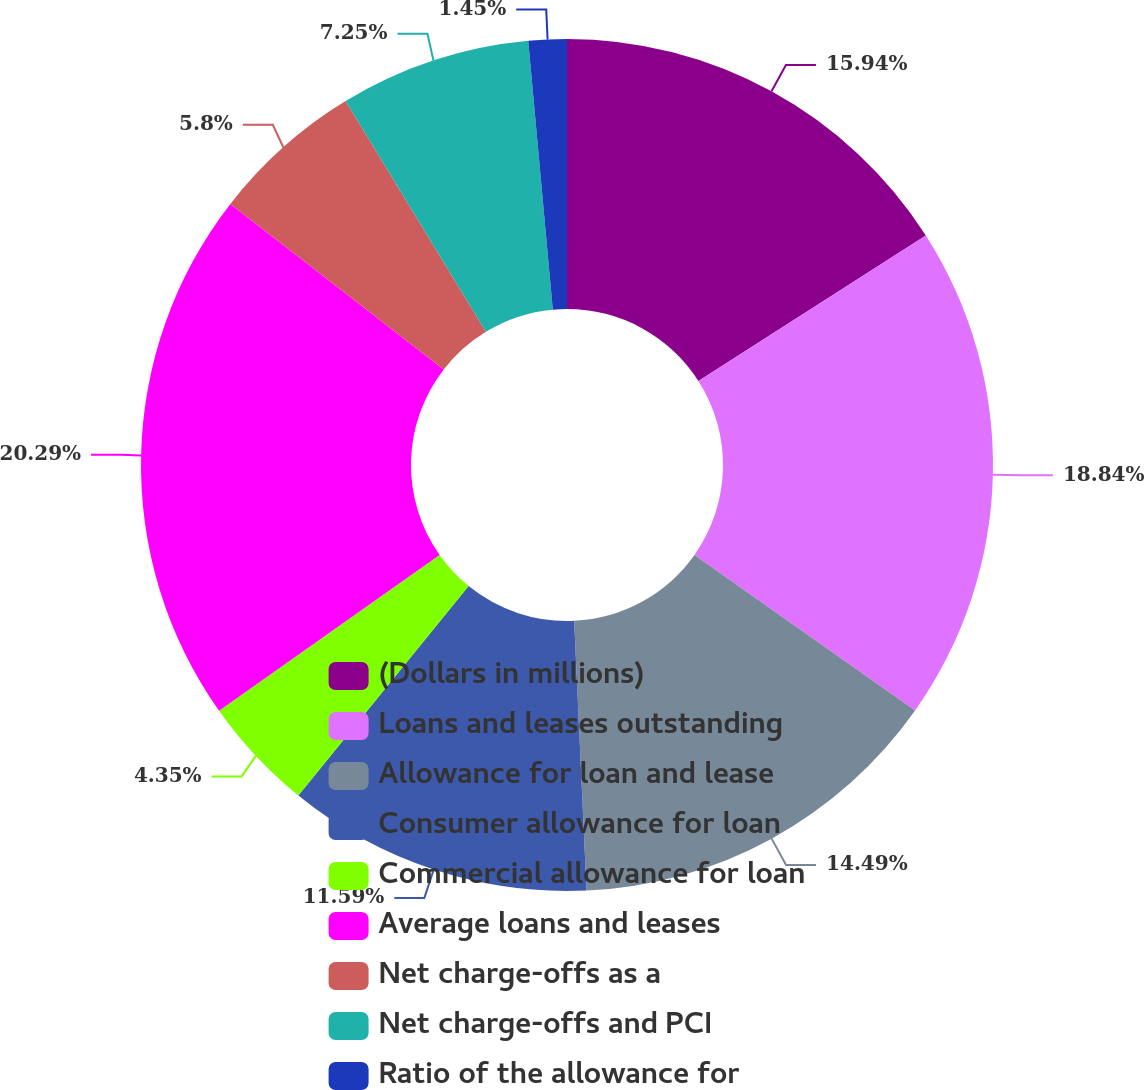<chart> <loc_0><loc_0><loc_500><loc_500><pie_chart><fcel>(Dollars in millions)<fcel>Loans and leases outstanding<fcel>Allowance for loan and lease<fcel>Consumer allowance for loan<fcel>Commercial allowance for loan<fcel>Average loans and leases<fcel>Net charge-offs as a<fcel>Net charge-offs and PCI<fcel>Ratio of the allowance for<nl><fcel>15.94%<fcel>18.84%<fcel>14.49%<fcel>11.59%<fcel>4.35%<fcel>20.29%<fcel>5.8%<fcel>7.25%<fcel>1.45%<nl></chart> 